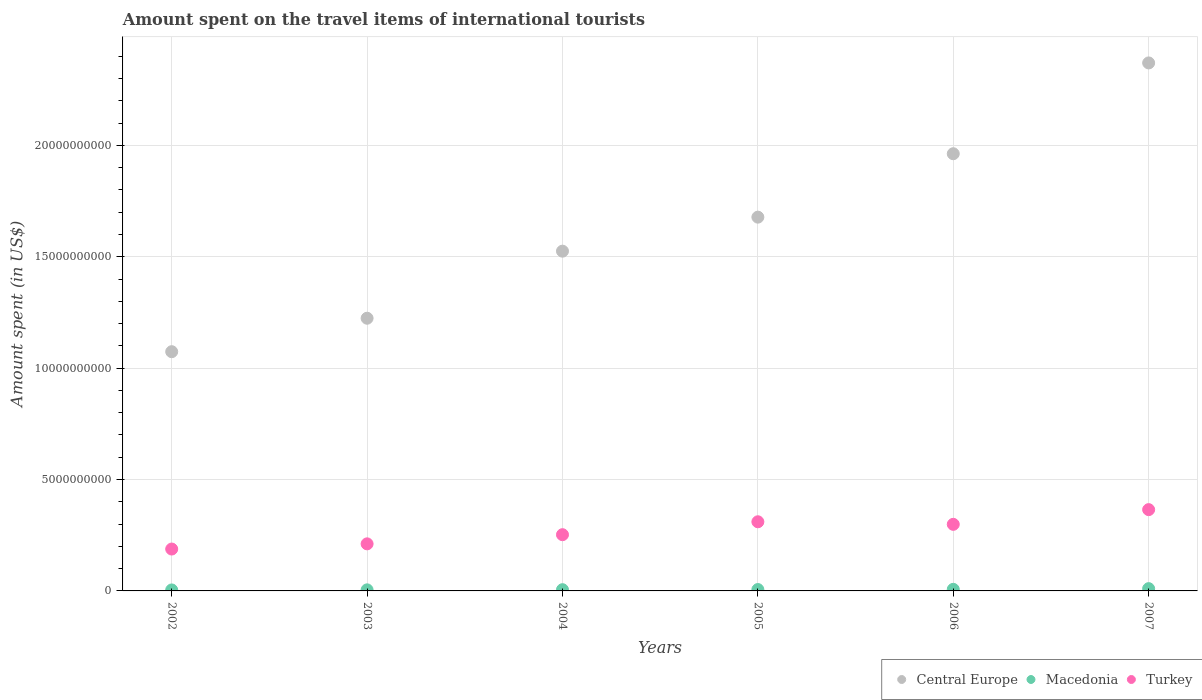How many different coloured dotlines are there?
Ensure brevity in your answer.  3. What is the amount spent on the travel items of international tourists in Turkey in 2003?
Your response must be concise. 2.11e+09. Across all years, what is the maximum amount spent on the travel items of international tourists in Turkey?
Ensure brevity in your answer.  3.65e+09. Across all years, what is the minimum amount spent on the travel items of international tourists in Macedonia?
Your answer should be very brief. 4.40e+07. What is the total amount spent on the travel items of international tourists in Central Europe in the graph?
Your answer should be compact. 9.83e+1. What is the difference between the amount spent on the travel items of international tourists in Macedonia in 2002 and that in 2004?
Offer a very short reply. -1.10e+07. What is the difference between the amount spent on the travel items of international tourists in Macedonia in 2004 and the amount spent on the travel items of international tourists in Central Europe in 2005?
Your response must be concise. -1.67e+1. What is the average amount spent on the travel items of international tourists in Macedonia per year?
Your answer should be compact. 6.37e+07. In the year 2002, what is the difference between the amount spent on the travel items of international tourists in Macedonia and amount spent on the travel items of international tourists in Central Europe?
Give a very brief answer. -1.07e+1. In how many years, is the amount spent on the travel items of international tourists in Macedonia greater than 19000000000 US$?
Offer a terse response. 0. What is the ratio of the amount spent on the travel items of international tourists in Macedonia in 2003 to that in 2007?
Offer a terse response. 0.47. What is the difference between the highest and the second highest amount spent on the travel items of international tourists in Macedonia?
Provide a short and direct response. 3.10e+07. What is the difference between the highest and the lowest amount spent on the travel items of international tourists in Turkey?
Your answer should be compact. 1.77e+09. In how many years, is the amount spent on the travel items of international tourists in Turkey greater than the average amount spent on the travel items of international tourists in Turkey taken over all years?
Make the answer very short. 3. Is it the case that in every year, the sum of the amount spent on the travel items of international tourists in Turkey and amount spent on the travel items of international tourists in Macedonia  is greater than the amount spent on the travel items of international tourists in Central Europe?
Offer a terse response. No. Does the amount spent on the travel items of international tourists in Central Europe monotonically increase over the years?
Keep it short and to the point. Yes. Is the amount spent on the travel items of international tourists in Macedonia strictly less than the amount spent on the travel items of international tourists in Central Europe over the years?
Your answer should be compact. Yes. How many years are there in the graph?
Make the answer very short. 6. What is the difference between two consecutive major ticks on the Y-axis?
Make the answer very short. 5.00e+09. Are the values on the major ticks of Y-axis written in scientific E-notation?
Your response must be concise. No. Where does the legend appear in the graph?
Provide a succinct answer. Bottom right. How are the legend labels stacked?
Keep it short and to the point. Horizontal. What is the title of the graph?
Make the answer very short. Amount spent on the travel items of international tourists. What is the label or title of the X-axis?
Your response must be concise. Years. What is the label or title of the Y-axis?
Keep it short and to the point. Amount spent (in US$). What is the Amount spent (in US$) in Central Europe in 2002?
Ensure brevity in your answer.  1.07e+1. What is the Amount spent (in US$) of Macedonia in 2002?
Your answer should be very brief. 4.40e+07. What is the Amount spent (in US$) of Turkey in 2002?
Make the answer very short. 1.88e+09. What is the Amount spent (in US$) of Central Europe in 2003?
Your answer should be compact. 1.22e+1. What is the Amount spent (in US$) of Macedonia in 2003?
Make the answer very short. 4.80e+07. What is the Amount spent (in US$) of Turkey in 2003?
Provide a short and direct response. 2.11e+09. What is the Amount spent (in US$) in Central Europe in 2004?
Give a very brief answer. 1.53e+1. What is the Amount spent (in US$) of Macedonia in 2004?
Your response must be concise. 5.50e+07. What is the Amount spent (in US$) in Turkey in 2004?
Provide a succinct answer. 2.52e+09. What is the Amount spent (in US$) in Central Europe in 2005?
Provide a short and direct response. 1.68e+1. What is the Amount spent (in US$) in Macedonia in 2005?
Your answer should be very brief. 6.20e+07. What is the Amount spent (in US$) of Turkey in 2005?
Offer a terse response. 3.10e+09. What is the Amount spent (in US$) of Central Europe in 2006?
Provide a succinct answer. 1.96e+1. What is the Amount spent (in US$) of Macedonia in 2006?
Your answer should be very brief. 7.10e+07. What is the Amount spent (in US$) in Turkey in 2006?
Provide a succinct answer. 2.99e+09. What is the Amount spent (in US$) of Central Europe in 2007?
Give a very brief answer. 2.37e+1. What is the Amount spent (in US$) of Macedonia in 2007?
Offer a terse response. 1.02e+08. What is the Amount spent (in US$) in Turkey in 2007?
Make the answer very short. 3.65e+09. Across all years, what is the maximum Amount spent (in US$) in Central Europe?
Provide a short and direct response. 2.37e+1. Across all years, what is the maximum Amount spent (in US$) of Macedonia?
Your answer should be very brief. 1.02e+08. Across all years, what is the maximum Amount spent (in US$) of Turkey?
Give a very brief answer. 3.65e+09. Across all years, what is the minimum Amount spent (in US$) of Central Europe?
Provide a succinct answer. 1.07e+1. Across all years, what is the minimum Amount spent (in US$) of Macedonia?
Your answer should be compact. 4.40e+07. Across all years, what is the minimum Amount spent (in US$) of Turkey?
Your answer should be compact. 1.88e+09. What is the total Amount spent (in US$) of Central Europe in the graph?
Provide a succinct answer. 9.83e+1. What is the total Amount spent (in US$) in Macedonia in the graph?
Your answer should be very brief. 3.82e+08. What is the total Amount spent (in US$) in Turkey in the graph?
Provide a short and direct response. 1.63e+1. What is the difference between the Amount spent (in US$) in Central Europe in 2002 and that in 2003?
Your answer should be very brief. -1.50e+09. What is the difference between the Amount spent (in US$) in Macedonia in 2002 and that in 2003?
Make the answer very short. -4.00e+06. What is the difference between the Amount spent (in US$) of Turkey in 2002 and that in 2003?
Give a very brief answer. -2.33e+08. What is the difference between the Amount spent (in US$) in Central Europe in 2002 and that in 2004?
Your response must be concise. -4.51e+09. What is the difference between the Amount spent (in US$) of Macedonia in 2002 and that in 2004?
Ensure brevity in your answer.  -1.10e+07. What is the difference between the Amount spent (in US$) of Turkey in 2002 and that in 2004?
Provide a short and direct response. -6.44e+08. What is the difference between the Amount spent (in US$) of Central Europe in 2002 and that in 2005?
Your response must be concise. -6.04e+09. What is the difference between the Amount spent (in US$) in Macedonia in 2002 and that in 2005?
Your answer should be compact. -1.80e+07. What is the difference between the Amount spent (in US$) of Turkey in 2002 and that in 2005?
Offer a terse response. -1.22e+09. What is the difference between the Amount spent (in US$) of Central Europe in 2002 and that in 2006?
Give a very brief answer. -8.89e+09. What is the difference between the Amount spent (in US$) in Macedonia in 2002 and that in 2006?
Make the answer very short. -2.70e+07. What is the difference between the Amount spent (in US$) of Turkey in 2002 and that in 2006?
Provide a short and direct response. -1.11e+09. What is the difference between the Amount spent (in US$) of Central Europe in 2002 and that in 2007?
Provide a succinct answer. -1.30e+1. What is the difference between the Amount spent (in US$) of Macedonia in 2002 and that in 2007?
Give a very brief answer. -5.80e+07. What is the difference between the Amount spent (in US$) of Turkey in 2002 and that in 2007?
Provide a succinct answer. -1.77e+09. What is the difference between the Amount spent (in US$) in Central Europe in 2003 and that in 2004?
Provide a succinct answer. -3.01e+09. What is the difference between the Amount spent (in US$) of Macedonia in 2003 and that in 2004?
Offer a very short reply. -7.00e+06. What is the difference between the Amount spent (in US$) of Turkey in 2003 and that in 2004?
Make the answer very short. -4.11e+08. What is the difference between the Amount spent (in US$) in Central Europe in 2003 and that in 2005?
Give a very brief answer. -4.54e+09. What is the difference between the Amount spent (in US$) of Macedonia in 2003 and that in 2005?
Make the answer very short. -1.40e+07. What is the difference between the Amount spent (in US$) of Turkey in 2003 and that in 2005?
Your answer should be compact. -9.91e+08. What is the difference between the Amount spent (in US$) in Central Europe in 2003 and that in 2006?
Provide a short and direct response. -7.38e+09. What is the difference between the Amount spent (in US$) of Macedonia in 2003 and that in 2006?
Offer a terse response. -2.30e+07. What is the difference between the Amount spent (in US$) in Turkey in 2003 and that in 2006?
Your answer should be very brief. -8.76e+08. What is the difference between the Amount spent (in US$) in Central Europe in 2003 and that in 2007?
Make the answer very short. -1.15e+1. What is the difference between the Amount spent (in US$) of Macedonia in 2003 and that in 2007?
Your answer should be compact. -5.40e+07. What is the difference between the Amount spent (in US$) of Turkey in 2003 and that in 2007?
Offer a very short reply. -1.54e+09. What is the difference between the Amount spent (in US$) of Central Europe in 2004 and that in 2005?
Your answer should be compact. -1.53e+09. What is the difference between the Amount spent (in US$) in Macedonia in 2004 and that in 2005?
Offer a terse response. -7.00e+06. What is the difference between the Amount spent (in US$) of Turkey in 2004 and that in 2005?
Your answer should be very brief. -5.80e+08. What is the difference between the Amount spent (in US$) in Central Europe in 2004 and that in 2006?
Provide a short and direct response. -4.37e+09. What is the difference between the Amount spent (in US$) in Macedonia in 2004 and that in 2006?
Provide a succinct answer. -1.60e+07. What is the difference between the Amount spent (in US$) in Turkey in 2004 and that in 2006?
Give a very brief answer. -4.65e+08. What is the difference between the Amount spent (in US$) of Central Europe in 2004 and that in 2007?
Your answer should be very brief. -8.45e+09. What is the difference between the Amount spent (in US$) in Macedonia in 2004 and that in 2007?
Your answer should be very brief. -4.70e+07. What is the difference between the Amount spent (in US$) of Turkey in 2004 and that in 2007?
Ensure brevity in your answer.  -1.12e+09. What is the difference between the Amount spent (in US$) in Central Europe in 2005 and that in 2006?
Offer a terse response. -2.85e+09. What is the difference between the Amount spent (in US$) in Macedonia in 2005 and that in 2006?
Provide a succinct answer. -9.00e+06. What is the difference between the Amount spent (in US$) of Turkey in 2005 and that in 2006?
Provide a succinct answer. 1.15e+08. What is the difference between the Amount spent (in US$) in Central Europe in 2005 and that in 2007?
Your answer should be very brief. -6.92e+09. What is the difference between the Amount spent (in US$) in Macedonia in 2005 and that in 2007?
Make the answer very short. -4.00e+07. What is the difference between the Amount spent (in US$) of Turkey in 2005 and that in 2007?
Provide a short and direct response. -5.45e+08. What is the difference between the Amount spent (in US$) in Central Europe in 2006 and that in 2007?
Provide a short and direct response. -4.08e+09. What is the difference between the Amount spent (in US$) in Macedonia in 2006 and that in 2007?
Your response must be concise. -3.10e+07. What is the difference between the Amount spent (in US$) of Turkey in 2006 and that in 2007?
Offer a terse response. -6.60e+08. What is the difference between the Amount spent (in US$) in Central Europe in 2002 and the Amount spent (in US$) in Macedonia in 2003?
Give a very brief answer. 1.07e+1. What is the difference between the Amount spent (in US$) of Central Europe in 2002 and the Amount spent (in US$) of Turkey in 2003?
Provide a succinct answer. 8.63e+09. What is the difference between the Amount spent (in US$) in Macedonia in 2002 and the Amount spent (in US$) in Turkey in 2003?
Your response must be concise. -2.07e+09. What is the difference between the Amount spent (in US$) in Central Europe in 2002 and the Amount spent (in US$) in Macedonia in 2004?
Your response must be concise. 1.07e+1. What is the difference between the Amount spent (in US$) of Central Europe in 2002 and the Amount spent (in US$) of Turkey in 2004?
Provide a succinct answer. 8.22e+09. What is the difference between the Amount spent (in US$) in Macedonia in 2002 and the Amount spent (in US$) in Turkey in 2004?
Your answer should be very brief. -2.48e+09. What is the difference between the Amount spent (in US$) of Central Europe in 2002 and the Amount spent (in US$) of Macedonia in 2005?
Your answer should be compact. 1.07e+1. What is the difference between the Amount spent (in US$) in Central Europe in 2002 and the Amount spent (in US$) in Turkey in 2005?
Give a very brief answer. 7.64e+09. What is the difference between the Amount spent (in US$) in Macedonia in 2002 and the Amount spent (in US$) in Turkey in 2005?
Keep it short and to the point. -3.06e+09. What is the difference between the Amount spent (in US$) in Central Europe in 2002 and the Amount spent (in US$) in Macedonia in 2006?
Offer a very short reply. 1.07e+1. What is the difference between the Amount spent (in US$) in Central Europe in 2002 and the Amount spent (in US$) in Turkey in 2006?
Your answer should be very brief. 7.75e+09. What is the difference between the Amount spent (in US$) in Macedonia in 2002 and the Amount spent (in US$) in Turkey in 2006?
Provide a short and direct response. -2.94e+09. What is the difference between the Amount spent (in US$) of Central Europe in 2002 and the Amount spent (in US$) of Macedonia in 2007?
Make the answer very short. 1.06e+1. What is the difference between the Amount spent (in US$) of Central Europe in 2002 and the Amount spent (in US$) of Turkey in 2007?
Your response must be concise. 7.09e+09. What is the difference between the Amount spent (in US$) in Macedonia in 2002 and the Amount spent (in US$) in Turkey in 2007?
Provide a short and direct response. -3.60e+09. What is the difference between the Amount spent (in US$) in Central Europe in 2003 and the Amount spent (in US$) in Macedonia in 2004?
Ensure brevity in your answer.  1.22e+1. What is the difference between the Amount spent (in US$) of Central Europe in 2003 and the Amount spent (in US$) of Turkey in 2004?
Give a very brief answer. 9.72e+09. What is the difference between the Amount spent (in US$) in Macedonia in 2003 and the Amount spent (in US$) in Turkey in 2004?
Provide a short and direct response. -2.48e+09. What is the difference between the Amount spent (in US$) of Central Europe in 2003 and the Amount spent (in US$) of Macedonia in 2005?
Provide a short and direct response. 1.22e+1. What is the difference between the Amount spent (in US$) of Central Europe in 2003 and the Amount spent (in US$) of Turkey in 2005?
Provide a short and direct response. 9.14e+09. What is the difference between the Amount spent (in US$) of Macedonia in 2003 and the Amount spent (in US$) of Turkey in 2005?
Your response must be concise. -3.06e+09. What is the difference between the Amount spent (in US$) of Central Europe in 2003 and the Amount spent (in US$) of Macedonia in 2006?
Your answer should be compact. 1.22e+1. What is the difference between the Amount spent (in US$) of Central Europe in 2003 and the Amount spent (in US$) of Turkey in 2006?
Ensure brevity in your answer.  9.25e+09. What is the difference between the Amount spent (in US$) in Macedonia in 2003 and the Amount spent (in US$) in Turkey in 2006?
Provide a succinct answer. -2.94e+09. What is the difference between the Amount spent (in US$) in Central Europe in 2003 and the Amount spent (in US$) in Macedonia in 2007?
Provide a short and direct response. 1.21e+1. What is the difference between the Amount spent (in US$) in Central Europe in 2003 and the Amount spent (in US$) in Turkey in 2007?
Provide a succinct answer. 8.59e+09. What is the difference between the Amount spent (in US$) of Macedonia in 2003 and the Amount spent (in US$) of Turkey in 2007?
Ensure brevity in your answer.  -3.60e+09. What is the difference between the Amount spent (in US$) in Central Europe in 2004 and the Amount spent (in US$) in Macedonia in 2005?
Keep it short and to the point. 1.52e+1. What is the difference between the Amount spent (in US$) in Central Europe in 2004 and the Amount spent (in US$) in Turkey in 2005?
Your answer should be compact. 1.21e+1. What is the difference between the Amount spent (in US$) of Macedonia in 2004 and the Amount spent (in US$) of Turkey in 2005?
Provide a succinct answer. -3.05e+09. What is the difference between the Amount spent (in US$) of Central Europe in 2004 and the Amount spent (in US$) of Macedonia in 2006?
Give a very brief answer. 1.52e+1. What is the difference between the Amount spent (in US$) in Central Europe in 2004 and the Amount spent (in US$) in Turkey in 2006?
Your answer should be very brief. 1.23e+1. What is the difference between the Amount spent (in US$) in Macedonia in 2004 and the Amount spent (in US$) in Turkey in 2006?
Provide a short and direct response. -2.93e+09. What is the difference between the Amount spent (in US$) of Central Europe in 2004 and the Amount spent (in US$) of Macedonia in 2007?
Offer a very short reply. 1.52e+1. What is the difference between the Amount spent (in US$) in Central Europe in 2004 and the Amount spent (in US$) in Turkey in 2007?
Keep it short and to the point. 1.16e+1. What is the difference between the Amount spent (in US$) in Macedonia in 2004 and the Amount spent (in US$) in Turkey in 2007?
Your response must be concise. -3.59e+09. What is the difference between the Amount spent (in US$) of Central Europe in 2005 and the Amount spent (in US$) of Macedonia in 2006?
Ensure brevity in your answer.  1.67e+1. What is the difference between the Amount spent (in US$) in Central Europe in 2005 and the Amount spent (in US$) in Turkey in 2006?
Your response must be concise. 1.38e+1. What is the difference between the Amount spent (in US$) in Macedonia in 2005 and the Amount spent (in US$) in Turkey in 2006?
Your response must be concise. -2.93e+09. What is the difference between the Amount spent (in US$) in Central Europe in 2005 and the Amount spent (in US$) in Macedonia in 2007?
Your response must be concise. 1.67e+1. What is the difference between the Amount spent (in US$) of Central Europe in 2005 and the Amount spent (in US$) of Turkey in 2007?
Give a very brief answer. 1.31e+1. What is the difference between the Amount spent (in US$) in Macedonia in 2005 and the Amount spent (in US$) in Turkey in 2007?
Offer a terse response. -3.59e+09. What is the difference between the Amount spent (in US$) of Central Europe in 2006 and the Amount spent (in US$) of Macedonia in 2007?
Give a very brief answer. 1.95e+1. What is the difference between the Amount spent (in US$) in Central Europe in 2006 and the Amount spent (in US$) in Turkey in 2007?
Your response must be concise. 1.60e+1. What is the difference between the Amount spent (in US$) in Macedonia in 2006 and the Amount spent (in US$) in Turkey in 2007?
Your answer should be very brief. -3.58e+09. What is the average Amount spent (in US$) in Central Europe per year?
Keep it short and to the point. 1.64e+1. What is the average Amount spent (in US$) in Macedonia per year?
Your answer should be very brief. 6.37e+07. What is the average Amount spent (in US$) in Turkey per year?
Keep it short and to the point. 2.71e+09. In the year 2002, what is the difference between the Amount spent (in US$) of Central Europe and Amount spent (in US$) of Macedonia?
Give a very brief answer. 1.07e+1. In the year 2002, what is the difference between the Amount spent (in US$) of Central Europe and Amount spent (in US$) of Turkey?
Provide a succinct answer. 8.86e+09. In the year 2002, what is the difference between the Amount spent (in US$) in Macedonia and Amount spent (in US$) in Turkey?
Offer a very short reply. -1.84e+09. In the year 2003, what is the difference between the Amount spent (in US$) in Central Europe and Amount spent (in US$) in Macedonia?
Provide a short and direct response. 1.22e+1. In the year 2003, what is the difference between the Amount spent (in US$) of Central Europe and Amount spent (in US$) of Turkey?
Ensure brevity in your answer.  1.01e+1. In the year 2003, what is the difference between the Amount spent (in US$) of Macedonia and Amount spent (in US$) of Turkey?
Provide a short and direct response. -2.06e+09. In the year 2004, what is the difference between the Amount spent (in US$) of Central Europe and Amount spent (in US$) of Macedonia?
Your response must be concise. 1.52e+1. In the year 2004, what is the difference between the Amount spent (in US$) in Central Europe and Amount spent (in US$) in Turkey?
Make the answer very short. 1.27e+1. In the year 2004, what is the difference between the Amount spent (in US$) in Macedonia and Amount spent (in US$) in Turkey?
Offer a very short reply. -2.47e+09. In the year 2005, what is the difference between the Amount spent (in US$) of Central Europe and Amount spent (in US$) of Macedonia?
Offer a terse response. 1.67e+1. In the year 2005, what is the difference between the Amount spent (in US$) of Central Europe and Amount spent (in US$) of Turkey?
Ensure brevity in your answer.  1.37e+1. In the year 2005, what is the difference between the Amount spent (in US$) in Macedonia and Amount spent (in US$) in Turkey?
Ensure brevity in your answer.  -3.04e+09. In the year 2006, what is the difference between the Amount spent (in US$) of Central Europe and Amount spent (in US$) of Macedonia?
Offer a terse response. 1.96e+1. In the year 2006, what is the difference between the Amount spent (in US$) of Central Europe and Amount spent (in US$) of Turkey?
Your answer should be compact. 1.66e+1. In the year 2006, what is the difference between the Amount spent (in US$) in Macedonia and Amount spent (in US$) in Turkey?
Offer a very short reply. -2.92e+09. In the year 2007, what is the difference between the Amount spent (in US$) in Central Europe and Amount spent (in US$) in Macedonia?
Ensure brevity in your answer.  2.36e+1. In the year 2007, what is the difference between the Amount spent (in US$) in Central Europe and Amount spent (in US$) in Turkey?
Offer a very short reply. 2.01e+1. In the year 2007, what is the difference between the Amount spent (in US$) in Macedonia and Amount spent (in US$) in Turkey?
Offer a terse response. -3.55e+09. What is the ratio of the Amount spent (in US$) of Central Europe in 2002 to that in 2003?
Ensure brevity in your answer.  0.88. What is the ratio of the Amount spent (in US$) of Macedonia in 2002 to that in 2003?
Your answer should be compact. 0.92. What is the ratio of the Amount spent (in US$) of Turkey in 2002 to that in 2003?
Provide a short and direct response. 0.89. What is the ratio of the Amount spent (in US$) in Central Europe in 2002 to that in 2004?
Provide a succinct answer. 0.7. What is the ratio of the Amount spent (in US$) of Macedonia in 2002 to that in 2004?
Keep it short and to the point. 0.8. What is the ratio of the Amount spent (in US$) of Turkey in 2002 to that in 2004?
Provide a short and direct response. 0.74. What is the ratio of the Amount spent (in US$) in Central Europe in 2002 to that in 2005?
Make the answer very short. 0.64. What is the ratio of the Amount spent (in US$) in Macedonia in 2002 to that in 2005?
Ensure brevity in your answer.  0.71. What is the ratio of the Amount spent (in US$) in Turkey in 2002 to that in 2005?
Offer a very short reply. 0.61. What is the ratio of the Amount spent (in US$) in Central Europe in 2002 to that in 2006?
Make the answer very short. 0.55. What is the ratio of the Amount spent (in US$) of Macedonia in 2002 to that in 2006?
Offer a terse response. 0.62. What is the ratio of the Amount spent (in US$) in Turkey in 2002 to that in 2006?
Provide a succinct answer. 0.63. What is the ratio of the Amount spent (in US$) in Central Europe in 2002 to that in 2007?
Give a very brief answer. 0.45. What is the ratio of the Amount spent (in US$) in Macedonia in 2002 to that in 2007?
Give a very brief answer. 0.43. What is the ratio of the Amount spent (in US$) in Turkey in 2002 to that in 2007?
Provide a short and direct response. 0.52. What is the ratio of the Amount spent (in US$) of Central Europe in 2003 to that in 2004?
Ensure brevity in your answer.  0.8. What is the ratio of the Amount spent (in US$) in Macedonia in 2003 to that in 2004?
Offer a terse response. 0.87. What is the ratio of the Amount spent (in US$) in Turkey in 2003 to that in 2004?
Offer a very short reply. 0.84. What is the ratio of the Amount spent (in US$) of Central Europe in 2003 to that in 2005?
Make the answer very short. 0.73. What is the ratio of the Amount spent (in US$) in Macedonia in 2003 to that in 2005?
Provide a short and direct response. 0.77. What is the ratio of the Amount spent (in US$) in Turkey in 2003 to that in 2005?
Your answer should be very brief. 0.68. What is the ratio of the Amount spent (in US$) in Central Europe in 2003 to that in 2006?
Make the answer very short. 0.62. What is the ratio of the Amount spent (in US$) in Macedonia in 2003 to that in 2006?
Give a very brief answer. 0.68. What is the ratio of the Amount spent (in US$) of Turkey in 2003 to that in 2006?
Offer a very short reply. 0.71. What is the ratio of the Amount spent (in US$) in Central Europe in 2003 to that in 2007?
Your answer should be very brief. 0.52. What is the ratio of the Amount spent (in US$) in Macedonia in 2003 to that in 2007?
Provide a short and direct response. 0.47. What is the ratio of the Amount spent (in US$) of Turkey in 2003 to that in 2007?
Offer a very short reply. 0.58. What is the ratio of the Amount spent (in US$) in Central Europe in 2004 to that in 2005?
Make the answer very short. 0.91. What is the ratio of the Amount spent (in US$) of Macedonia in 2004 to that in 2005?
Keep it short and to the point. 0.89. What is the ratio of the Amount spent (in US$) in Turkey in 2004 to that in 2005?
Keep it short and to the point. 0.81. What is the ratio of the Amount spent (in US$) of Central Europe in 2004 to that in 2006?
Make the answer very short. 0.78. What is the ratio of the Amount spent (in US$) in Macedonia in 2004 to that in 2006?
Keep it short and to the point. 0.77. What is the ratio of the Amount spent (in US$) in Turkey in 2004 to that in 2006?
Provide a short and direct response. 0.84. What is the ratio of the Amount spent (in US$) of Central Europe in 2004 to that in 2007?
Offer a very short reply. 0.64. What is the ratio of the Amount spent (in US$) of Macedonia in 2004 to that in 2007?
Your response must be concise. 0.54. What is the ratio of the Amount spent (in US$) in Turkey in 2004 to that in 2007?
Offer a terse response. 0.69. What is the ratio of the Amount spent (in US$) of Central Europe in 2005 to that in 2006?
Provide a succinct answer. 0.85. What is the ratio of the Amount spent (in US$) in Macedonia in 2005 to that in 2006?
Provide a short and direct response. 0.87. What is the ratio of the Amount spent (in US$) of Central Europe in 2005 to that in 2007?
Keep it short and to the point. 0.71. What is the ratio of the Amount spent (in US$) in Macedonia in 2005 to that in 2007?
Your answer should be compact. 0.61. What is the ratio of the Amount spent (in US$) in Turkey in 2005 to that in 2007?
Your response must be concise. 0.85. What is the ratio of the Amount spent (in US$) of Central Europe in 2006 to that in 2007?
Your answer should be compact. 0.83. What is the ratio of the Amount spent (in US$) of Macedonia in 2006 to that in 2007?
Offer a terse response. 0.7. What is the ratio of the Amount spent (in US$) in Turkey in 2006 to that in 2007?
Your answer should be compact. 0.82. What is the difference between the highest and the second highest Amount spent (in US$) in Central Europe?
Provide a succinct answer. 4.08e+09. What is the difference between the highest and the second highest Amount spent (in US$) of Macedonia?
Make the answer very short. 3.10e+07. What is the difference between the highest and the second highest Amount spent (in US$) of Turkey?
Provide a succinct answer. 5.45e+08. What is the difference between the highest and the lowest Amount spent (in US$) of Central Europe?
Give a very brief answer. 1.30e+1. What is the difference between the highest and the lowest Amount spent (in US$) of Macedonia?
Make the answer very short. 5.80e+07. What is the difference between the highest and the lowest Amount spent (in US$) of Turkey?
Offer a terse response. 1.77e+09. 